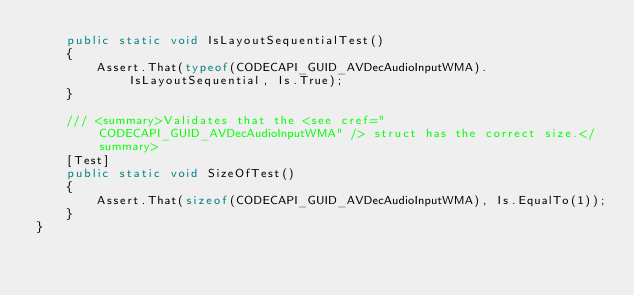Convert code to text. <code><loc_0><loc_0><loc_500><loc_500><_C#_>    public static void IsLayoutSequentialTest()
    {
        Assert.That(typeof(CODECAPI_GUID_AVDecAudioInputWMA).IsLayoutSequential, Is.True);
    }

    /// <summary>Validates that the <see cref="CODECAPI_GUID_AVDecAudioInputWMA" /> struct has the correct size.</summary>
    [Test]
    public static void SizeOfTest()
    {
        Assert.That(sizeof(CODECAPI_GUID_AVDecAudioInputWMA), Is.EqualTo(1));
    }
}
</code> 